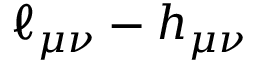<formula> <loc_0><loc_0><loc_500><loc_500>\ell _ { \mu \nu } - h _ { \mu \nu }</formula> 